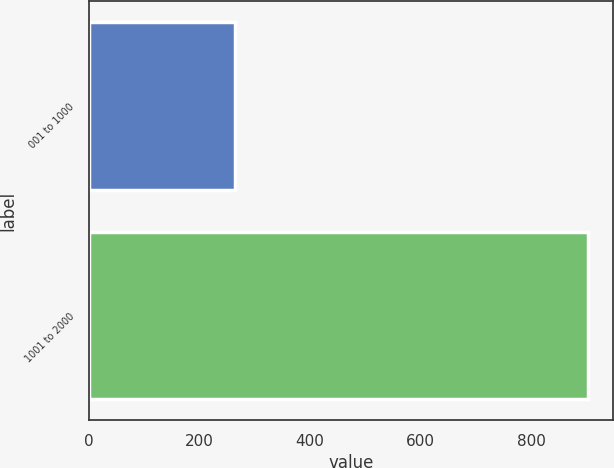Convert chart to OTSL. <chart><loc_0><loc_0><loc_500><loc_500><bar_chart><fcel>001 to 1000<fcel>1001 to 2000<nl><fcel>264<fcel>904<nl></chart> 